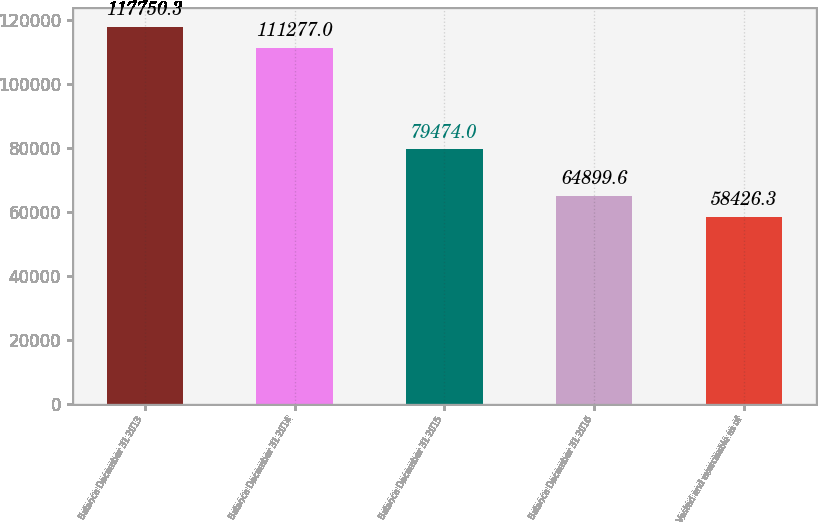<chart> <loc_0><loc_0><loc_500><loc_500><bar_chart><fcel>Balance December 31 2013<fcel>Balance December 31 2014<fcel>Balance December 31 2015<fcel>Balance December 31 2016<fcel>Vested and exercisable as of<nl><fcel>117750<fcel>111277<fcel>79474<fcel>64899.6<fcel>58426.3<nl></chart> 